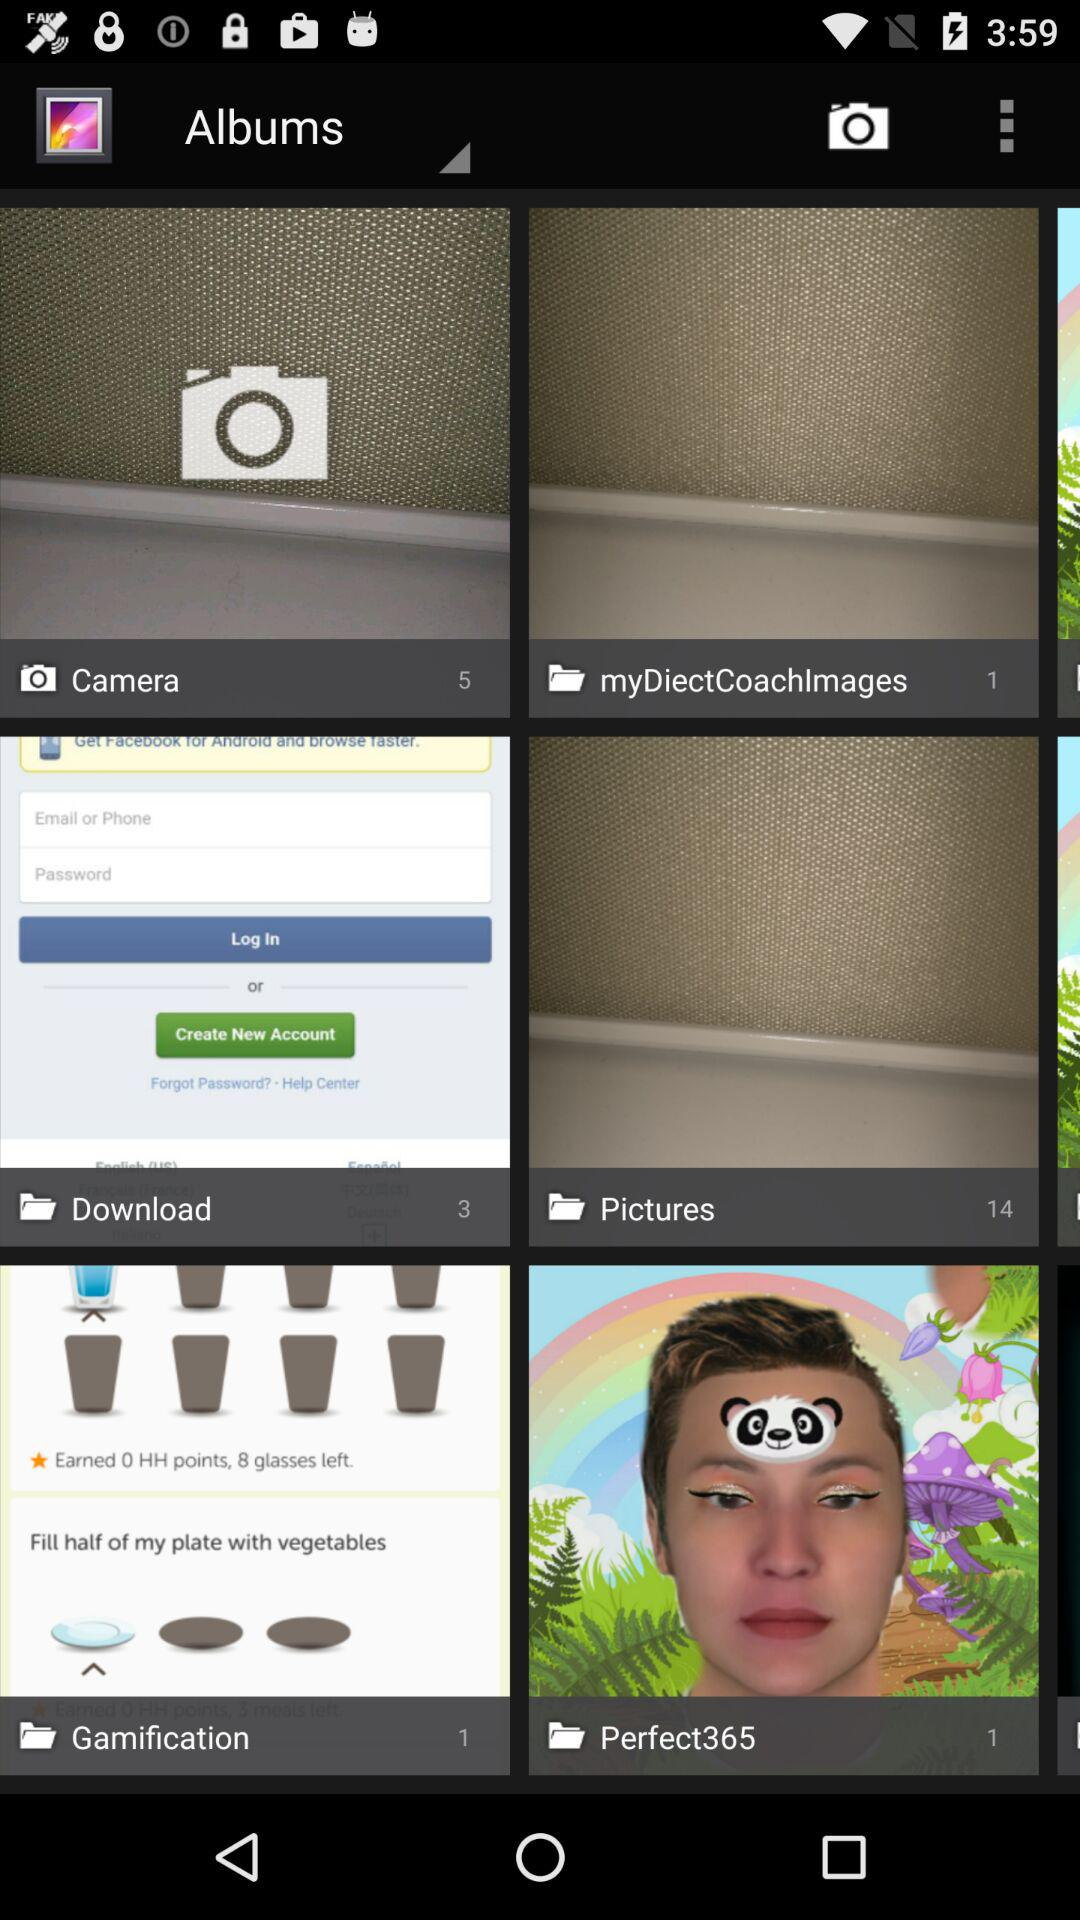What is the count of photos in the download folder? The count of photos is 3. 